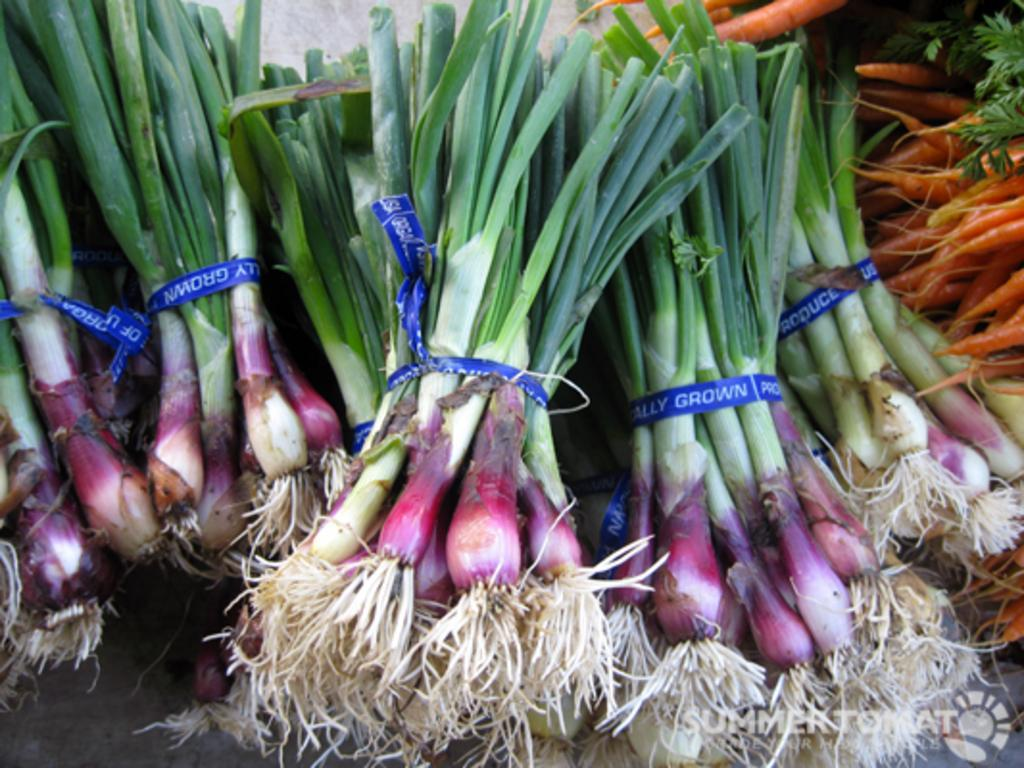What type of vegetables are present in the image? There are spring onions and carrots in the image. Can you describe any other features of the image? There is a logo with text at the bottom of the image. How many centimeters long is the fly in the image? There is no fly present in the image, so it is not possible to determine its length. 